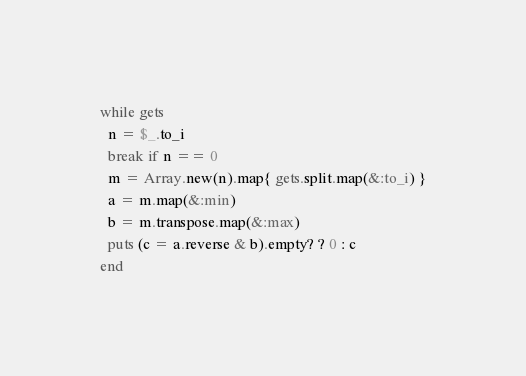Convert code to text. <code><loc_0><loc_0><loc_500><loc_500><_Ruby_>while gets
  n = $_.to_i
  break if n == 0
  m = Array.new(n).map{ gets.split.map(&:to_i) }
  a = m.map(&:min)
  b = m.transpose.map(&:max)
  puts (c = a.reverse & b).empty? ? 0 : c
end</code> 